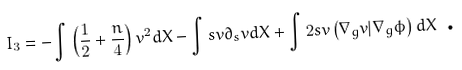Convert formula to latex. <formula><loc_0><loc_0><loc_500><loc_500>I _ { 3 } = - \int \left ( \frac { 1 } { 2 } + \frac { n } { 4 } \right ) v ^ { 2 } d X - \int s v \partial _ { s } v d X + \int 2 s v \left ( \nabla _ { g } v | \nabla _ { g } \phi \right ) d X \text { .}</formula> 